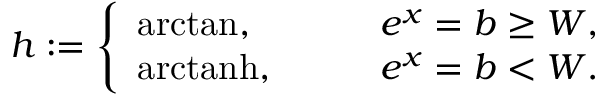Convert formula to latex. <formula><loc_0><loc_0><loc_500><loc_500>h \colon = \left \{ \begin{array} { l l } { a r c t a n , \quad } & { e ^ { x } = b \geq W , } \\ { a r c t a n h , \quad } & { e ^ { x } = b < W . } \end{array}</formula> 